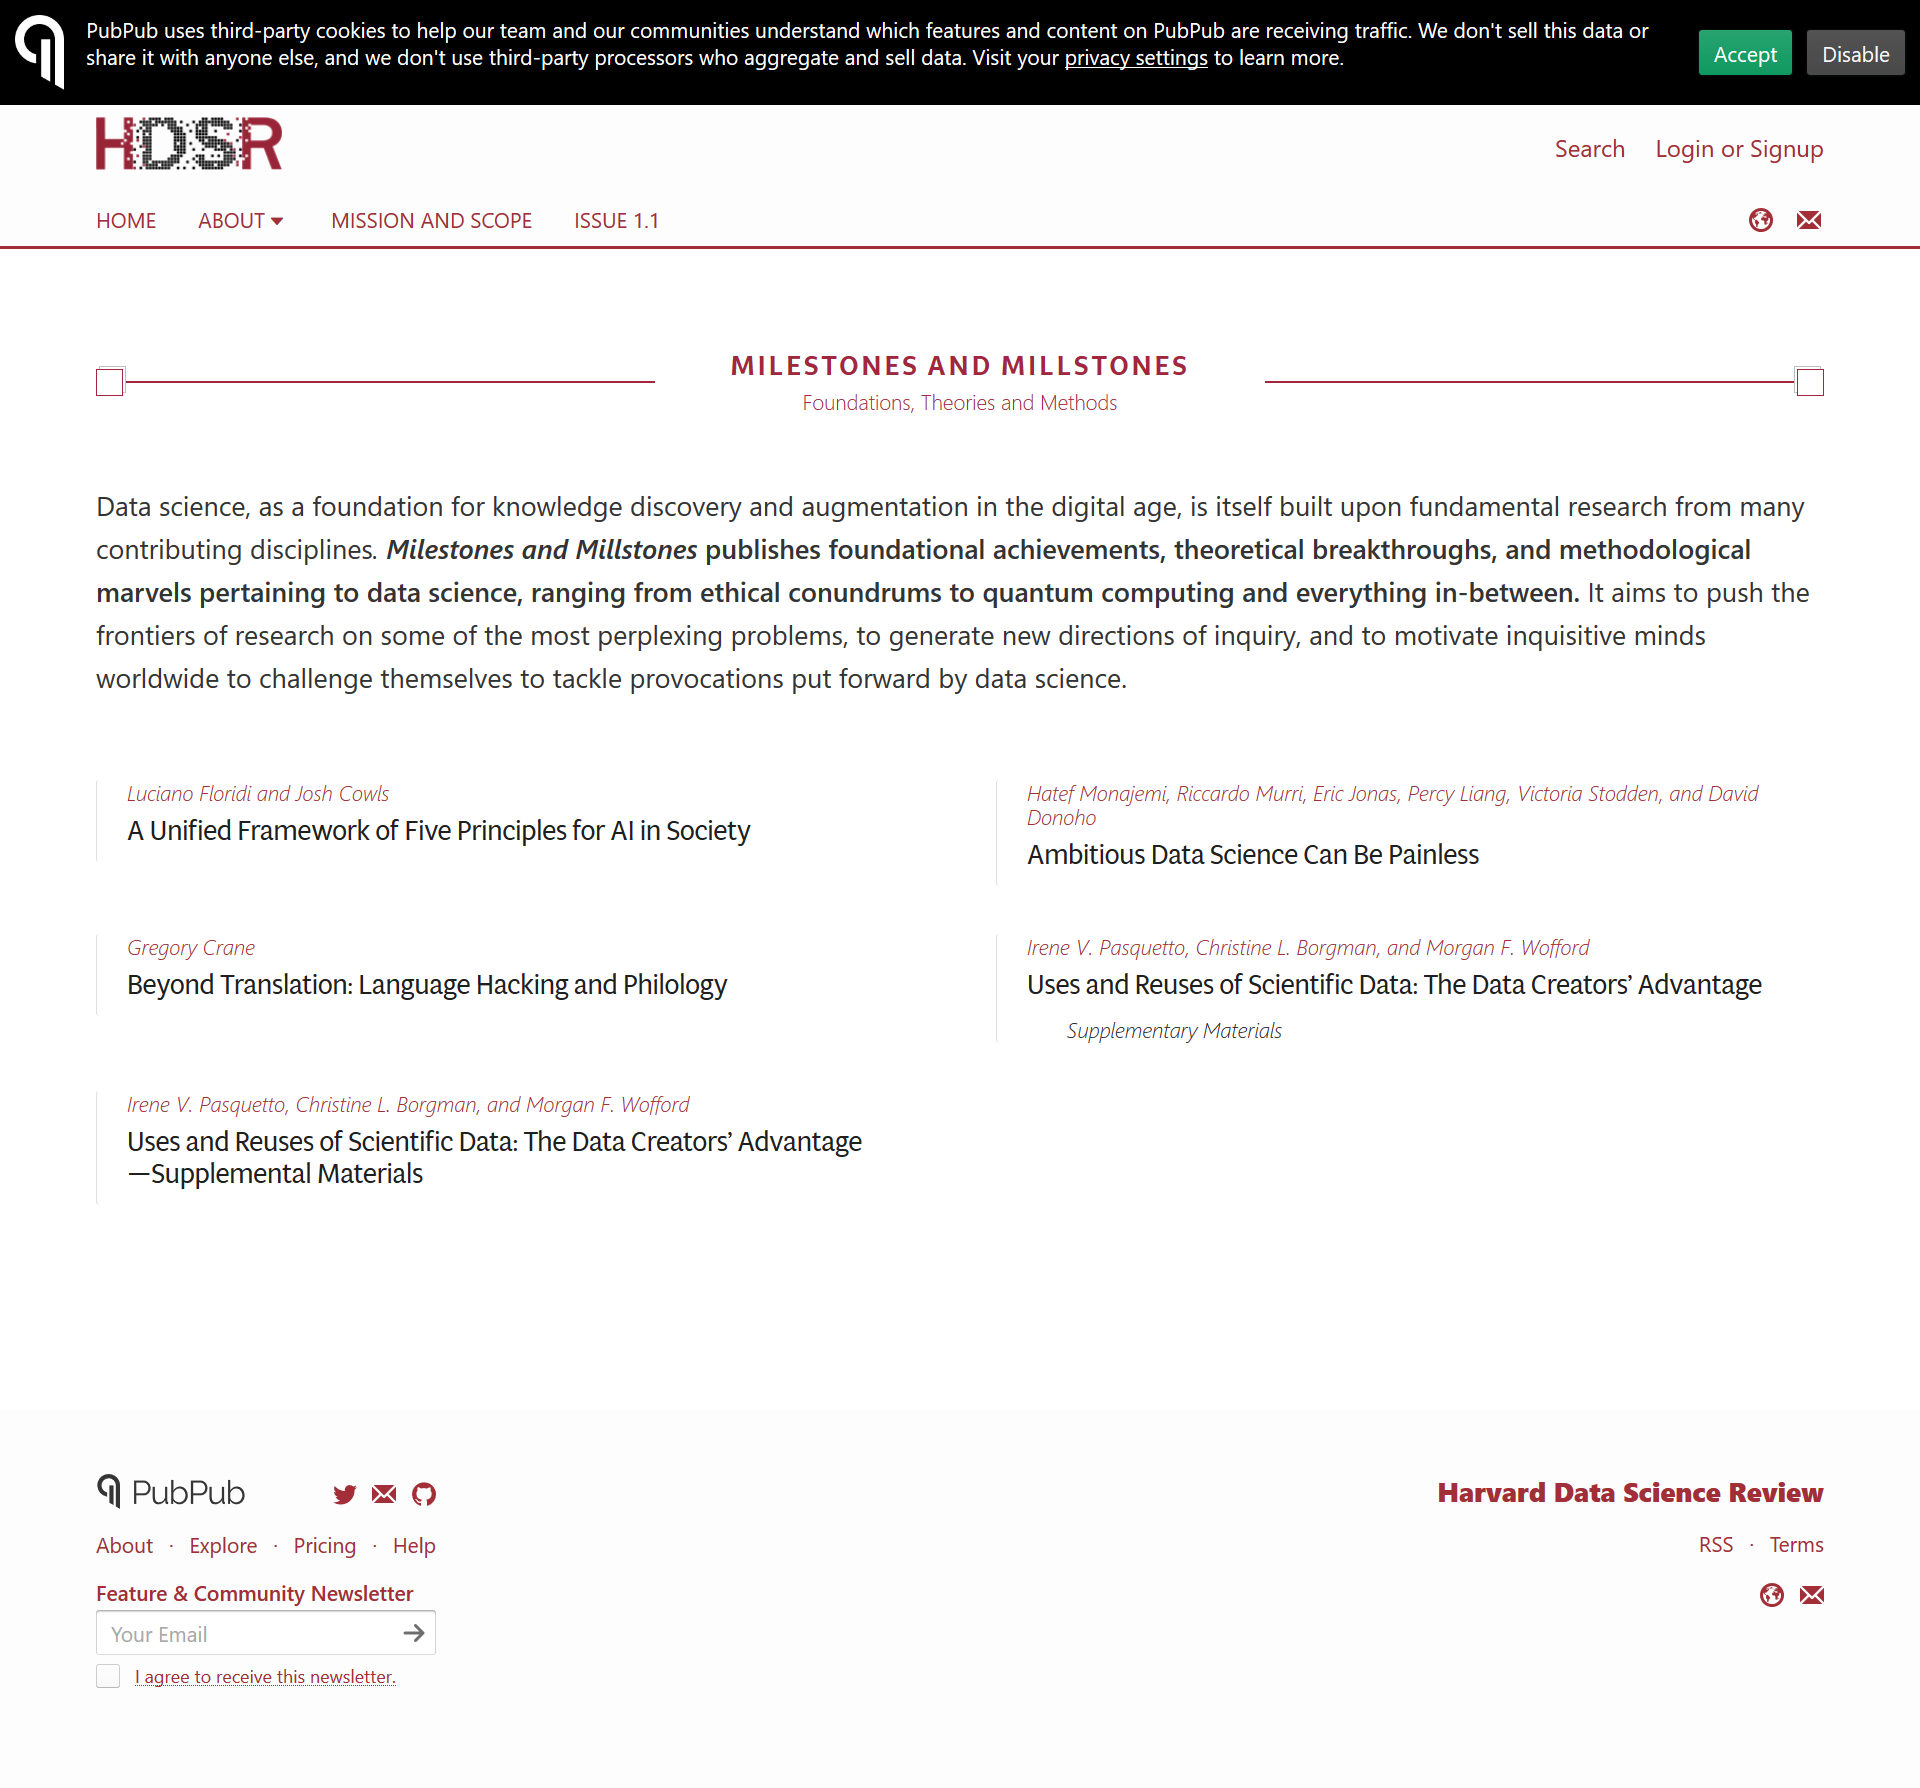Give some essential details in this illustration. Milestone and Millstone publish in three key areas, specifically Foundation, Theories, and Methods. Milestones and Millstones are engaged in research in the field of data science, specifically focusing on areas of inquiry related to this discipline. Data science is a field that draws from a wide range of disciplines, including statistics, computer science, and domain-specific expertise. It leverages data and analytical methods to extract insights, support decision-making, and drive innovation across various industries. The field of data science is built upon a foundation of research from multiple disciplines, encompassing machine learning, natural language processing, data visualization, and more. 